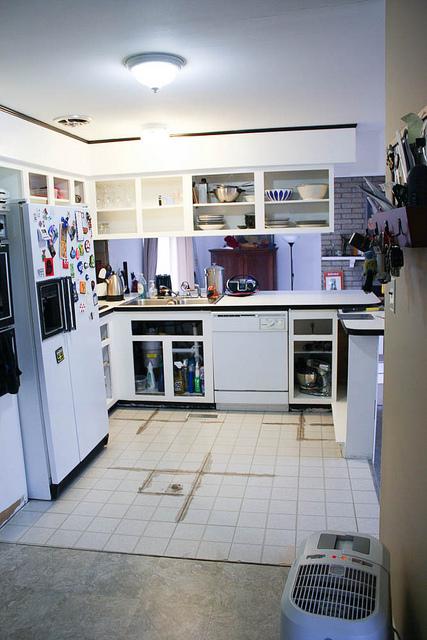How many cabinets in the background are empty?
Answer briefly. 4. What is the main color of this room?
Concise answer only. White. Are there people in the room?
Answer briefly. No. Is this a bathroom?
Keep it brief. No. 